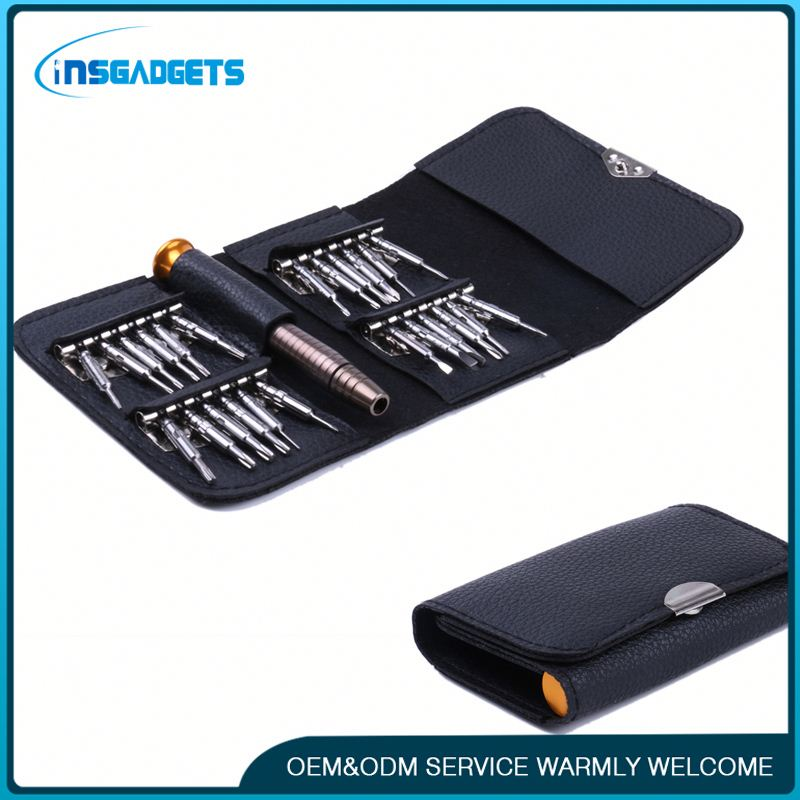What kind of tools are depicted in this image? The image depicts a set of precision screwdrivers commonly used for delicate and detailed work, such as repairing electronics, assembling small mechanical devices, or other tasks requiring precision tools. This set includes various interchangeable bits and a secure case for organized storage. Could this set be used by hobbyists as well as professionals? Yes, this precision screwdriver set is versatile and can be used by both hobbyists and professionals. Hobbyists can use it for DIY projects, electronics repair, and crafting, while professionals might use it in more specialized fields such as computer and smartphone repair, eyeglass assembly, or intricate mechanical work. The range of bits included and the compact, organized carrying case make it suitable for various detailed tasks. 